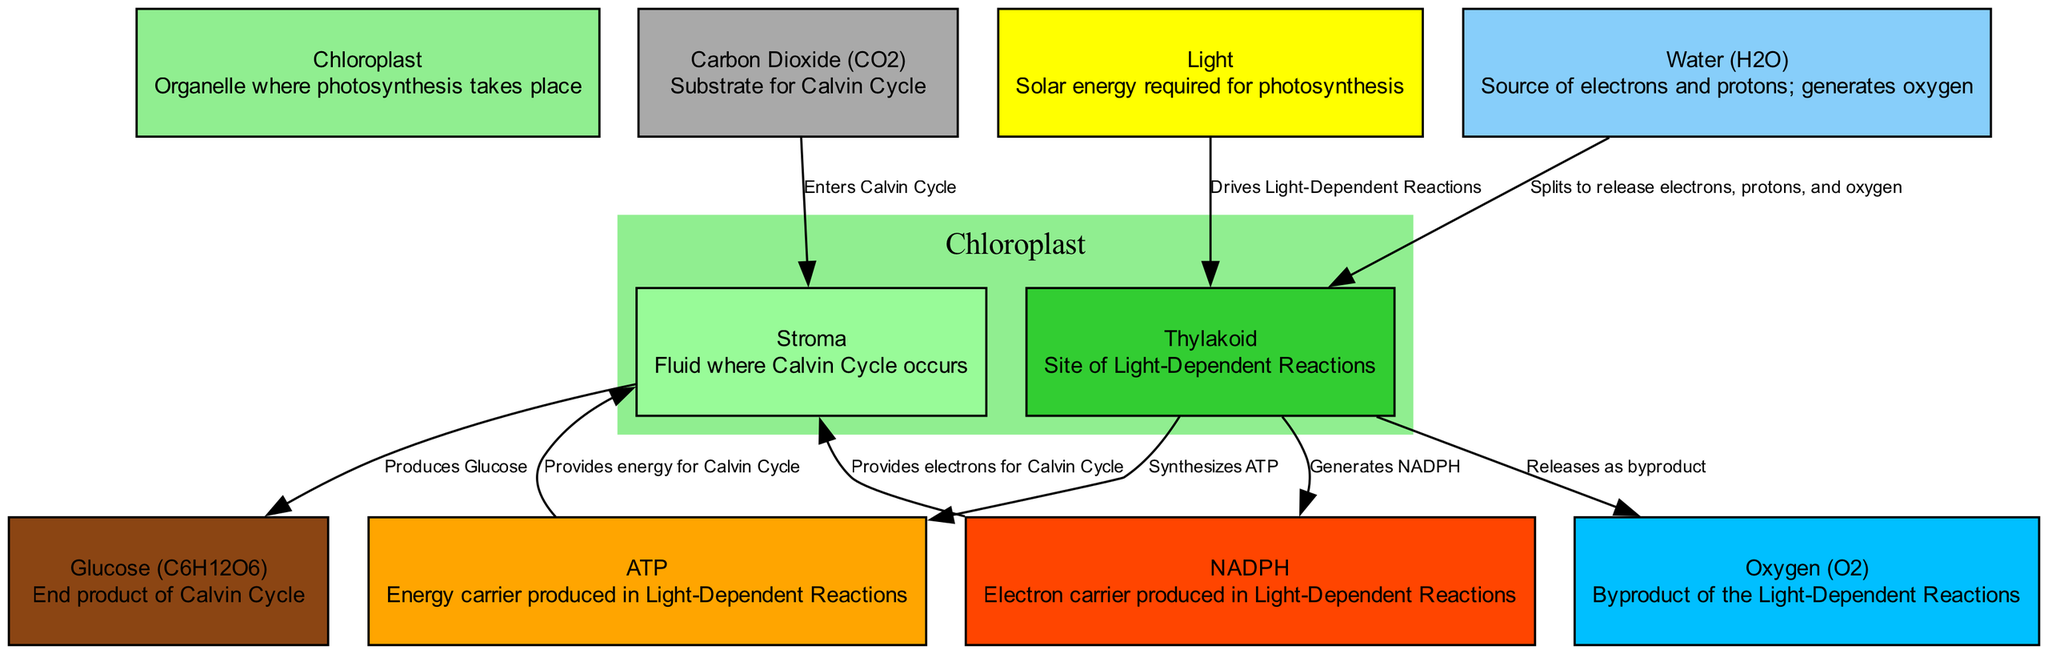What is the organelle where photosynthesis occurs? The diagram identifies the "Chloroplast" as the organelle where photosynthesis takes place. This can be found clearly labeled in the nodes of the diagram.
Answer: Chloroplast Which process takes place in the Thylakoid? The diagram indicates that the "Light-Dependent Reactions" occur in the Thylakoid. This relationship is shown directly in the description associated with the Thylakoid node.
Answer: Light-Dependent Reactions What byproduct is released during the Light-Dependent Reactions? From the diagram, it is indicated that "Oxygen" is released as a byproduct. This information is explicitly mentioned in the edge that connects Thylakoid to Oxygen.
Answer: Oxygen How many main components are involved in the Calvin Cycle? By examining the edges that connect to the Stroma (which is where the Calvin Cycle occurs), we find three components: Carbon Dioxide, ATP, and NADPH. So, there are three main components involved.
Answer: Three What compound is produced as the end product of the Calvin Cycle? The diagram indicates that "Glucose" is the end product formed in the Stroma. This is clearly labeled in the node for Glucose, which is connected to Stroma.
Answer: Glucose What is the initial source of energy that drives the Light-Dependent Reactions? The diagram specifies that "Light" is the initial source of energy for the Light-Dependent Reactions, as shown in the edge connecting Light to Thylakoid.
Answer: Light What happens to Water in the Thylakoid? The diagram shows that Water splits in the Thylakoid to release electrons, protons, and oxygen. This information is conveyed through the edge connecting Water to Thylakoid, which elaborates on the process.
Answer: Splits to release electrons, protons, and oxygen Which two molecules provide substances for the Calvin Cycle? The edges show that ATP and NADPH provide energy and electrons, respectively, for the Calvin Cycle. They connect to Stroma, confirming their roles in facilitating the Calvin Cycle.
Answer: ATP and NADPH How does carbon dioxide enter the Calvin Cycle? The diagram illustrates that Carbon Dioxide enters the Stroma, which is where the Calvin Cycle takes place. The edge from Carbon Dioxide to Stroma confirms this entry point.
Answer: Enters Calvin Cycle 